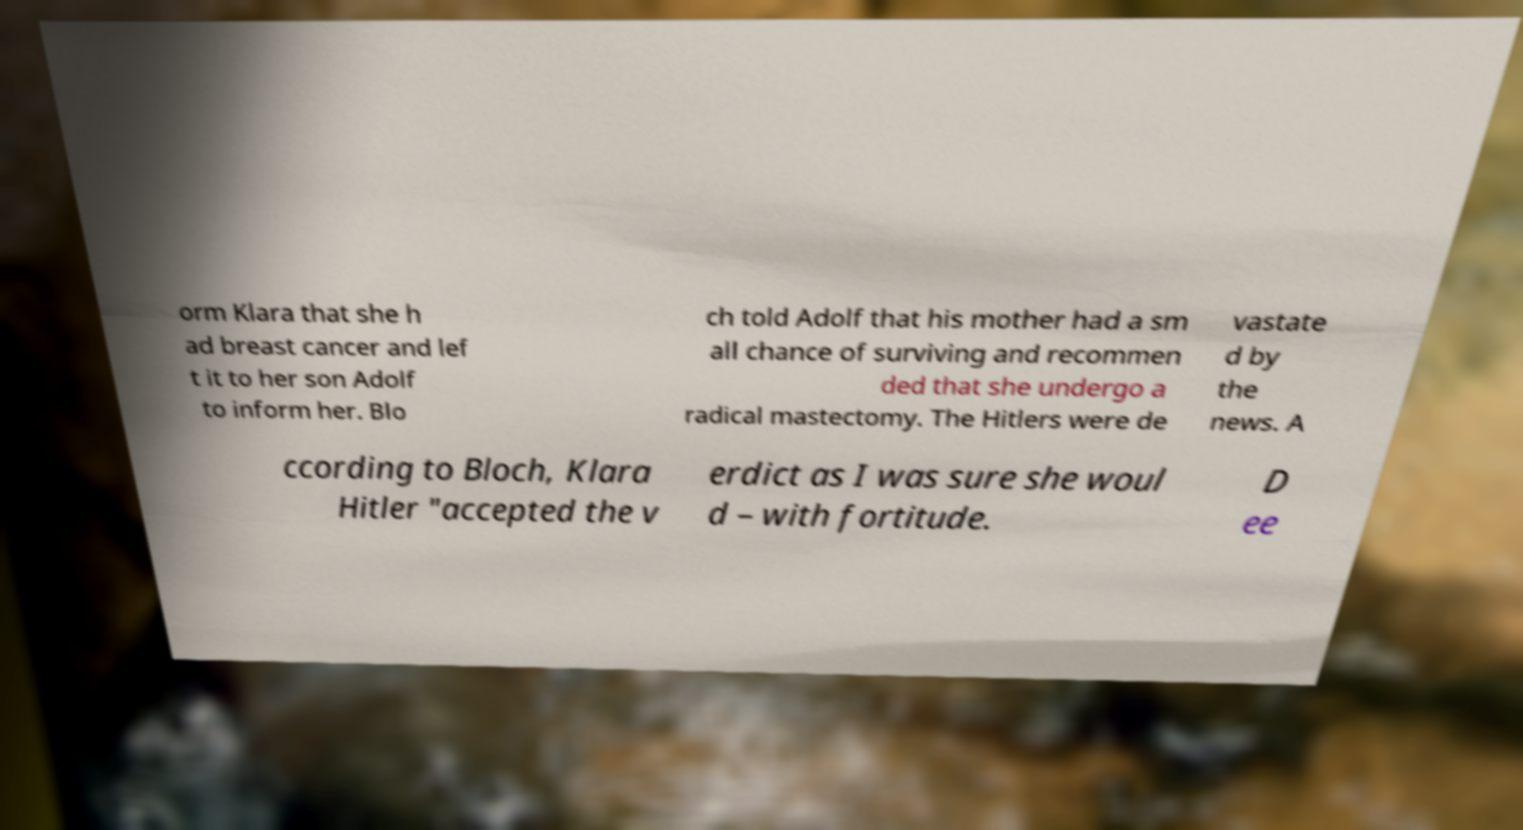Could you extract and type out the text from this image? orm Klara that she h ad breast cancer and lef t it to her son Adolf to inform her. Blo ch told Adolf that his mother had a sm all chance of surviving and recommen ded that she undergo a radical mastectomy. The Hitlers were de vastate d by the news. A ccording to Bloch, Klara Hitler "accepted the v erdict as I was sure she woul d – with fortitude. D ee 